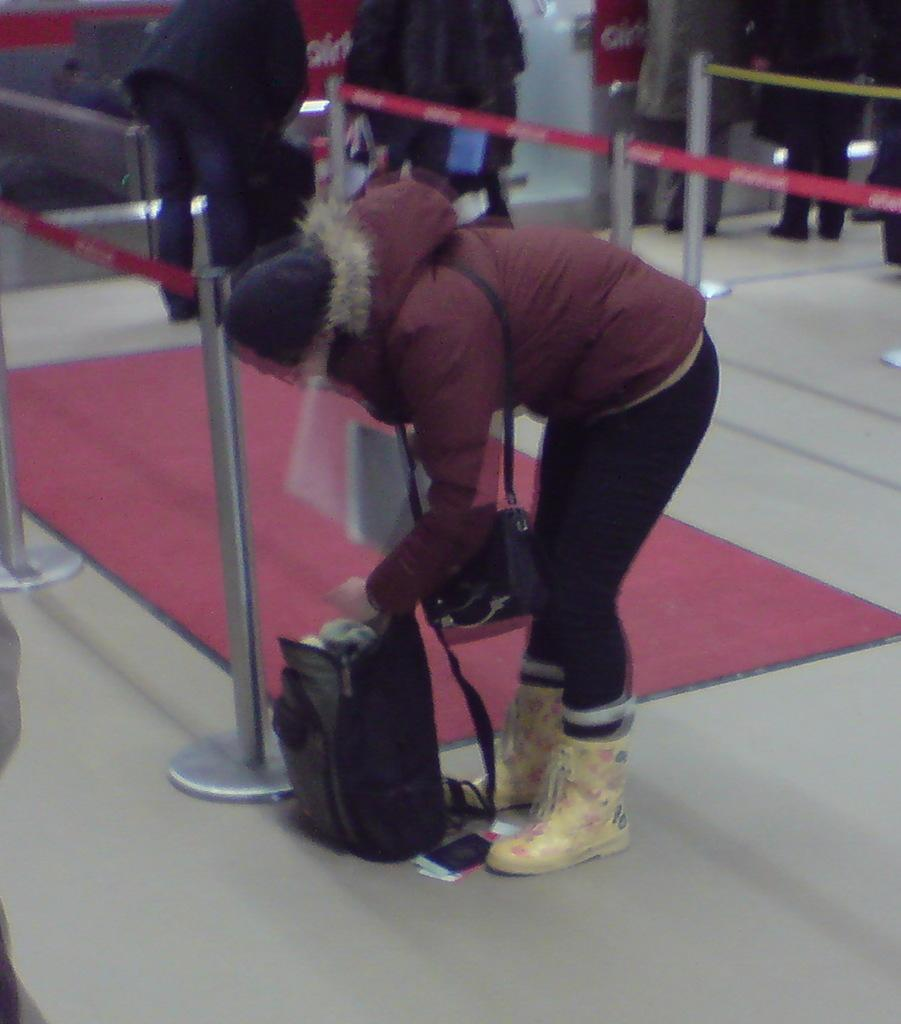Who is the main subject in the image? There is a lady in the image. What is the lady doing in the image? The lady is bending and taking items from her bag. What can be seen in the background of the image? There are poles and people standing in the background of the image. What is on the floor in the image? There is a mat on the floor in the image. What type of feast is being prepared by the band in the image? There is no feast or band present in the image. How does the lady's action in the image relate to the concept of death? The lady's action in the image, bending and taking items from her bag, does not relate to the concept of death. 